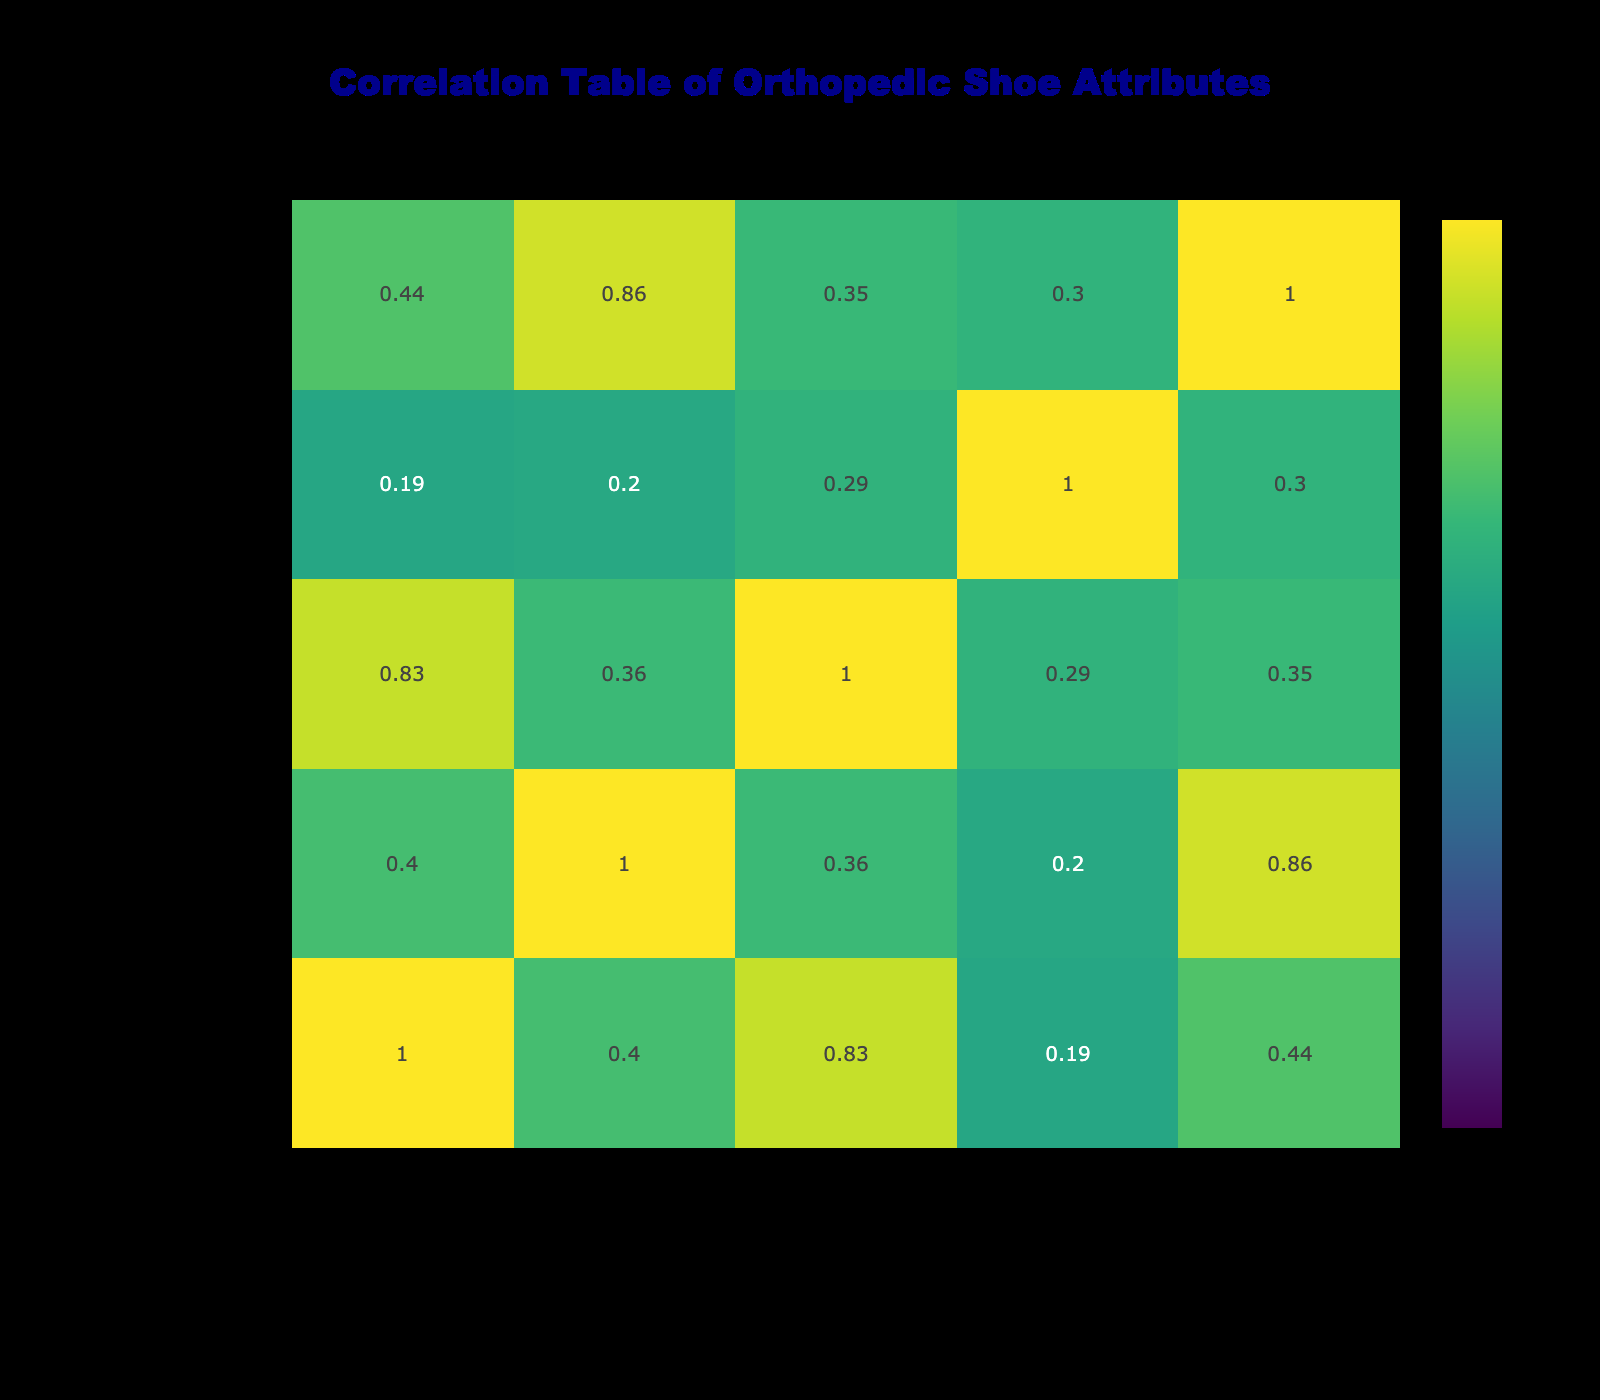What brand has the highest comfort rating? Looking at the comfort ratings in the table, Hoka One One has the highest rating of 9.5.
Answer: Hoka One One Is there a correlation between weight and comfort rating? The correlation can be evaluated by examining the correlation coefficient in the table. In this case, we would see that there might be a negative correlation since lighter shoes like Hoka One One have higher comfort ratings while heavier brands tend to score slightly lower.
Answer: Yes, there is a negative correlation What is the average arch support rating for shoes with a comfort rating above 8.5? The shoes with a comfort rating above 8.5 are New Balance, Birkenstock, Hoka One One, and Vionic. Their arch support ratings are 9, 8, 8, and 9 respectively. Adding these ratings (9 + 8 + 8 + 9 = 34) gives a sum of 34. There are 4 brands so the average is 34/4 = 8.5.
Answer: 8.5 Is the cushioning level higher for lightweight shoes compared to heavier ones? To assess this, we compare the average cushioning levels of lightweight shoes (those weighing 10 oz or less) versus heavier shoes (those weighing more than 10 oz). Lightweight shoes (Hoka One One, Skechers, Asics) have cushioning levels of 9, 8 and 8 respectively (average = 8.33), while heavier shoes (Birkenstock, Brooks, Orthofeet, Clarks) have cushioning levels of 9, 8, 9, and 7 respectively (average = 8.25). Hence, there is no substantial difference in average cushioning levels.
Answer: No Does higher durability rating correlate with higher weight in shoes? We can evaluate their correlation by comparing the durability ratings with weight. Looking at the entries: higher weights do not consistently translate to higher durability. For instance, New Balance (10.5 oz) has a durability rating of 9, and Vionic (10 oz) has a rating of 8. Therefore, we cannot say there is a strong correlation between them.
Answer: No, there is no strong correlation 